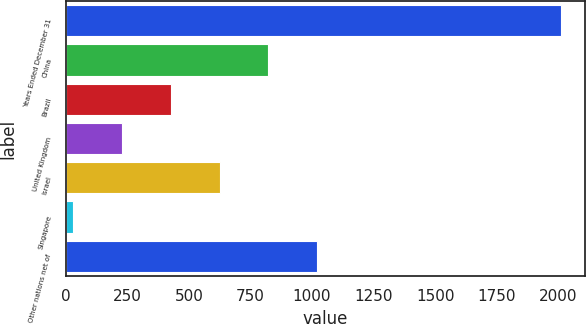Convert chart. <chart><loc_0><loc_0><loc_500><loc_500><bar_chart><fcel>Years Ended December 31<fcel>China<fcel>Brazil<fcel>United Kingdom<fcel>Israel<fcel>Singapore<fcel>Other nations net of<nl><fcel>2008<fcel>822.4<fcel>427.2<fcel>229.6<fcel>624.8<fcel>32<fcel>1020<nl></chart> 